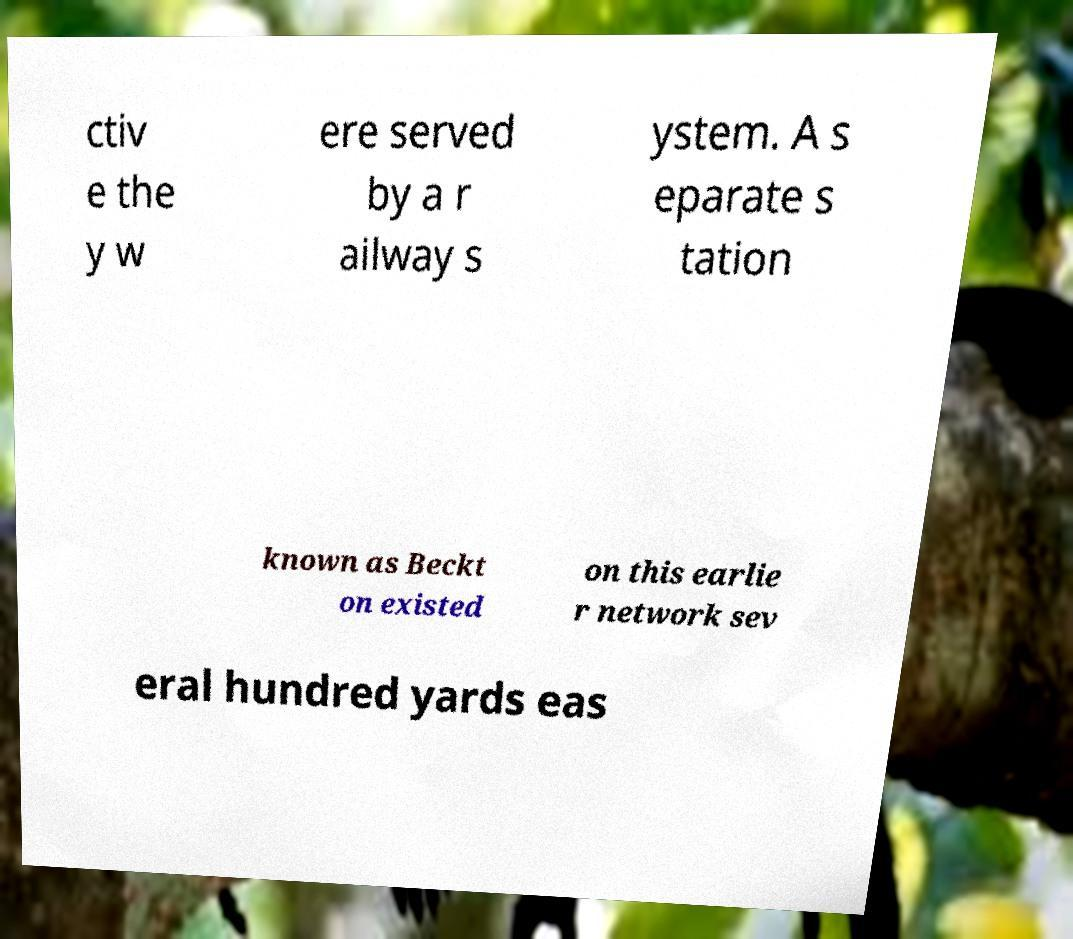I need the written content from this picture converted into text. Can you do that? ctiv e the y w ere served by a r ailway s ystem. A s eparate s tation known as Beckt on existed on this earlie r network sev eral hundred yards eas 